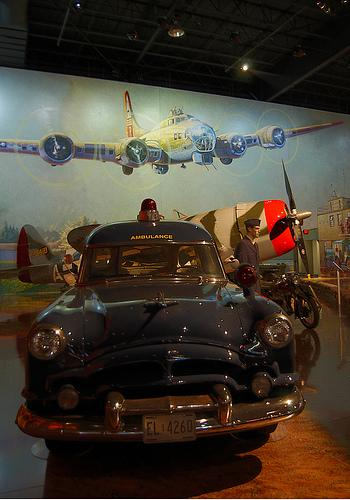Provide a brief description of the dominant objects shown in the image. The image features a vintage airplane painted on a wall, an old-fashioned blue ambulance, a male statue wearing a uniform, and various details related to cars, motorcycles, and buildings. Which object in the image appears to have a painted tree and grass? The wall has a painted tree and grass on it. Help me understand the emotions or feelings the image might evoke. The image may evoke feelings of nostalgia, fascination, and curiosity as it displays various vintage and historic objects in an artistic manner. In the image, is the airplane on the wall painted in camouflage or a different style? The airplane on the wall is painted in camouflage. What components of an antique car can be distinguished in the image according to the given coordinates? The components of an antique car that can be distinguished are the hood ornament, headlights, front grill, bumper, license plate, lettering, and number on the car. Describe the various components of the vintage ambulance displayed in the image. The vintage ambulance has a blue color, white and yellow signage, red and silver light, headlights, silver bumper, and a white license plate with numbers on it. Based on the given information, how many headlights are visible in the image? There are four visible headlights. Tell me if the license plate is white or black, according to the given information. The license plate is white and black. How many significant objects can be identified in the image? There are 43 significant objects identified in the image. Are the headlights of the older model car flashing and multicolored? No, it's not mentioned in the image. Does the old-fashioned ambulance have purple flames painted on its side? The ambulance in the image is described as being painted blue, not having purple flames on the side. Is the license plate on the car covered with cartoon stickers and written in a foreign language? The license plate is described as being white and black, with no mention of stickers or foreign language lettering. Is the male statue wearing a fedora and sunglasses? The male statue is described as wearing a uniform cap, not a fedora, and there is no mention of sunglasses. 